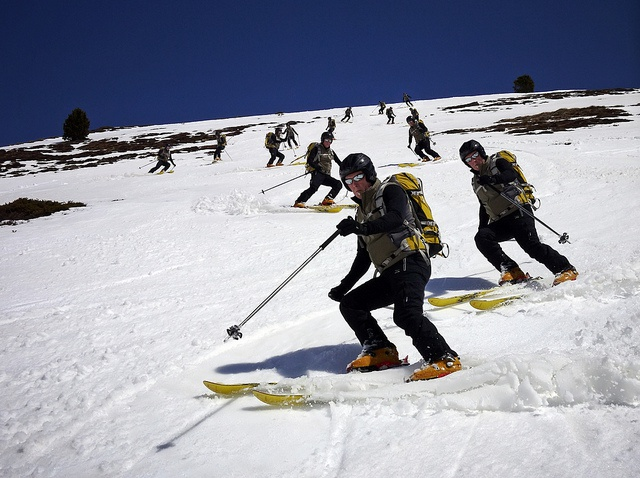Describe the objects in this image and their specific colors. I can see people in navy, black, gray, white, and olive tones, people in navy, black, gray, lightgray, and maroon tones, people in navy, lightgray, black, and darkgray tones, backpack in navy, black, gray, olive, and lightgray tones, and people in navy, black, gray, maroon, and darkgray tones in this image. 